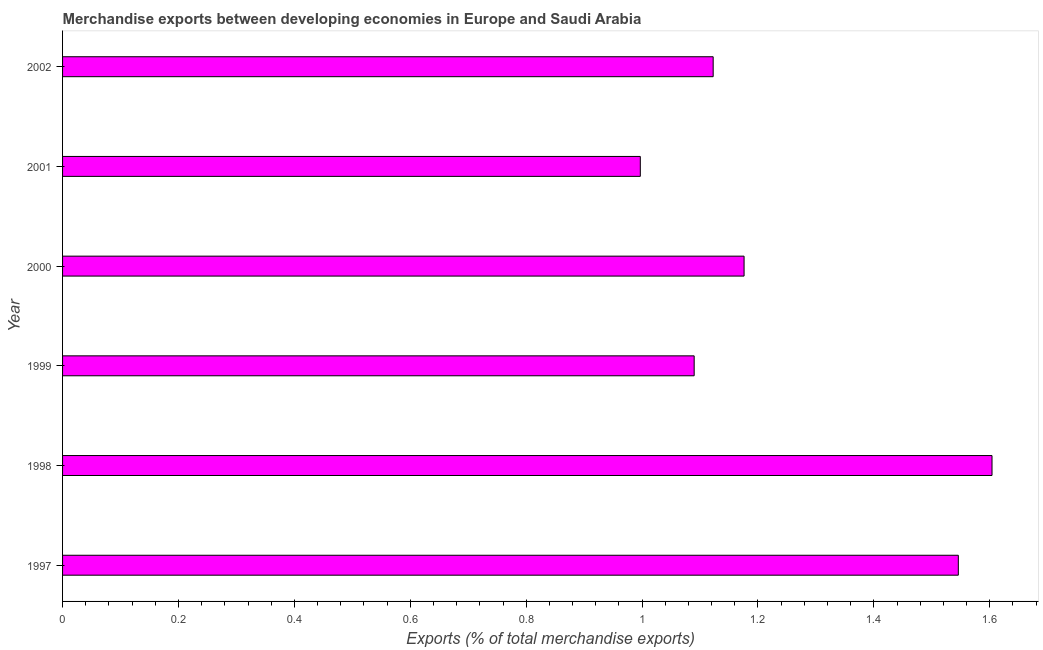Does the graph contain grids?
Give a very brief answer. No. What is the title of the graph?
Offer a very short reply. Merchandise exports between developing economies in Europe and Saudi Arabia. What is the label or title of the X-axis?
Offer a very short reply. Exports (% of total merchandise exports). What is the merchandise exports in 2002?
Keep it short and to the point. 1.12. Across all years, what is the maximum merchandise exports?
Give a very brief answer. 1.6. Across all years, what is the minimum merchandise exports?
Your answer should be very brief. 1. In which year was the merchandise exports maximum?
Provide a short and direct response. 1998. What is the sum of the merchandise exports?
Your answer should be compact. 7.54. What is the difference between the merchandise exports in 1999 and 2002?
Provide a short and direct response. -0.03. What is the average merchandise exports per year?
Provide a succinct answer. 1.26. What is the median merchandise exports?
Provide a short and direct response. 1.15. In how many years, is the merchandise exports greater than 1.04 %?
Keep it short and to the point. 5. Do a majority of the years between 2002 and 1998 (inclusive) have merchandise exports greater than 0.36 %?
Give a very brief answer. Yes. What is the ratio of the merchandise exports in 1997 to that in 2000?
Keep it short and to the point. 1.31. Is the merchandise exports in 1999 less than that in 2000?
Your answer should be compact. Yes. What is the difference between the highest and the second highest merchandise exports?
Your answer should be compact. 0.06. Is the sum of the merchandise exports in 1998 and 2000 greater than the maximum merchandise exports across all years?
Provide a short and direct response. Yes. What is the difference between the highest and the lowest merchandise exports?
Your response must be concise. 0.61. Are all the bars in the graph horizontal?
Ensure brevity in your answer.  Yes. What is the difference between two consecutive major ticks on the X-axis?
Provide a succinct answer. 0.2. Are the values on the major ticks of X-axis written in scientific E-notation?
Make the answer very short. No. What is the Exports (% of total merchandise exports) in 1997?
Provide a succinct answer. 1.55. What is the Exports (% of total merchandise exports) in 1998?
Give a very brief answer. 1.6. What is the Exports (% of total merchandise exports) in 1999?
Provide a short and direct response. 1.09. What is the Exports (% of total merchandise exports) of 2000?
Ensure brevity in your answer.  1.18. What is the Exports (% of total merchandise exports) of 2001?
Make the answer very short. 1. What is the Exports (% of total merchandise exports) in 2002?
Keep it short and to the point. 1.12. What is the difference between the Exports (% of total merchandise exports) in 1997 and 1998?
Provide a short and direct response. -0.06. What is the difference between the Exports (% of total merchandise exports) in 1997 and 1999?
Your answer should be very brief. 0.46. What is the difference between the Exports (% of total merchandise exports) in 1997 and 2000?
Give a very brief answer. 0.37. What is the difference between the Exports (% of total merchandise exports) in 1997 and 2001?
Your response must be concise. 0.55. What is the difference between the Exports (% of total merchandise exports) in 1997 and 2002?
Your answer should be compact. 0.42. What is the difference between the Exports (% of total merchandise exports) in 1998 and 1999?
Your answer should be very brief. 0.51. What is the difference between the Exports (% of total merchandise exports) in 1998 and 2000?
Your answer should be very brief. 0.43. What is the difference between the Exports (% of total merchandise exports) in 1998 and 2001?
Offer a very short reply. 0.61. What is the difference between the Exports (% of total merchandise exports) in 1998 and 2002?
Your answer should be compact. 0.48. What is the difference between the Exports (% of total merchandise exports) in 1999 and 2000?
Give a very brief answer. -0.09. What is the difference between the Exports (% of total merchandise exports) in 1999 and 2001?
Your response must be concise. 0.09. What is the difference between the Exports (% of total merchandise exports) in 1999 and 2002?
Provide a short and direct response. -0.03. What is the difference between the Exports (% of total merchandise exports) in 2000 and 2001?
Offer a terse response. 0.18. What is the difference between the Exports (% of total merchandise exports) in 2000 and 2002?
Provide a short and direct response. 0.05. What is the difference between the Exports (% of total merchandise exports) in 2001 and 2002?
Offer a terse response. -0.13. What is the ratio of the Exports (% of total merchandise exports) in 1997 to that in 1998?
Provide a succinct answer. 0.96. What is the ratio of the Exports (% of total merchandise exports) in 1997 to that in 1999?
Your answer should be compact. 1.42. What is the ratio of the Exports (% of total merchandise exports) in 1997 to that in 2000?
Your response must be concise. 1.31. What is the ratio of the Exports (% of total merchandise exports) in 1997 to that in 2001?
Ensure brevity in your answer.  1.55. What is the ratio of the Exports (% of total merchandise exports) in 1997 to that in 2002?
Provide a succinct answer. 1.38. What is the ratio of the Exports (% of total merchandise exports) in 1998 to that in 1999?
Keep it short and to the point. 1.47. What is the ratio of the Exports (% of total merchandise exports) in 1998 to that in 2000?
Your answer should be very brief. 1.36. What is the ratio of the Exports (% of total merchandise exports) in 1998 to that in 2001?
Provide a short and direct response. 1.61. What is the ratio of the Exports (% of total merchandise exports) in 1998 to that in 2002?
Ensure brevity in your answer.  1.43. What is the ratio of the Exports (% of total merchandise exports) in 1999 to that in 2000?
Your answer should be very brief. 0.93. What is the ratio of the Exports (% of total merchandise exports) in 1999 to that in 2001?
Your response must be concise. 1.09. What is the ratio of the Exports (% of total merchandise exports) in 1999 to that in 2002?
Offer a terse response. 0.97. What is the ratio of the Exports (% of total merchandise exports) in 2000 to that in 2001?
Provide a succinct answer. 1.18. What is the ratio of the Exports (% of total merchandise exports) in 2000 to that in 2002?
Offer a terse response. 1.05. What is the ratio of the Exports (% of total merchandise exports) in 2001 to that in 2002?
Give a very brief answer. 0.89. 